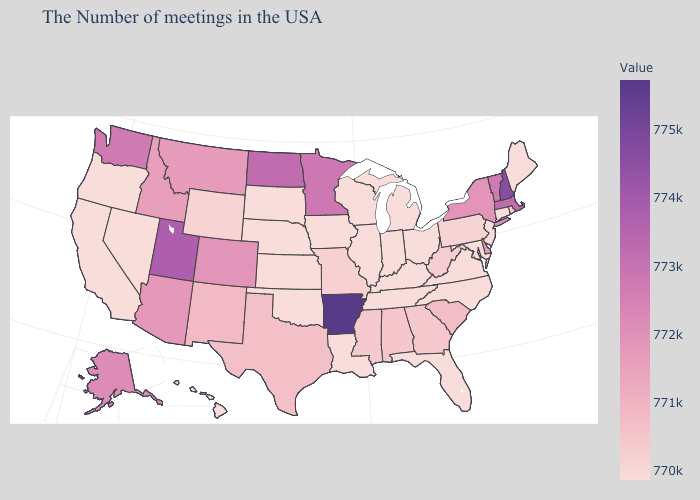Does New Hampshire have the highest value in the Northeast?
Give a very brief answer. Yes. Does Kentucky have a lower value than Vermont?
Be succinct. Yes. Does Hawaii have the lowest value in the West?
Answer briefly. Yes. Does Nevada have the lowest value in the West?
Write a very short answer. Yes. Among the states that border Vermont , does Massachusetts have the highest value?
Short answer required. No. Is the legend a continuous bar?
Give a very brief answer. Yes. 